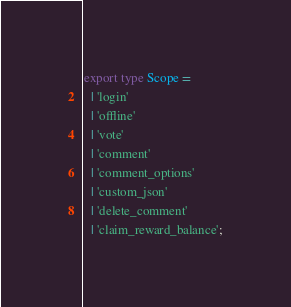<code> <loc_0><loc_0><loc_500><loc_500><_TypeScript_>export type Scope =
  | 'login'
  | 'offline'
  | 'vote'
  | 'comment'
  | 'comment_options'
  | 'custom_json'
  | 'delete_comment'
  | 'claim_reward_balance';
</code> 